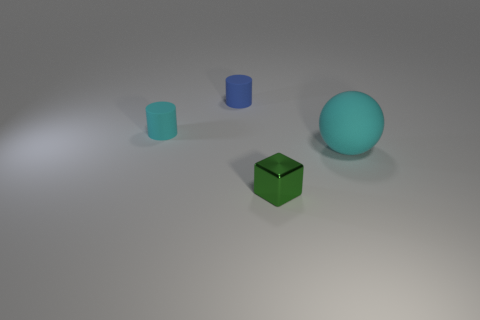Add 2 small green objects. How many objects exist? 6 Subtract all balls. How many objects are left? 3 Add 1 small cyan objects. How many small cyan objects exist? 2 Subtract 0 yellow blocks. How many objects are left? 4 Subtract all tiny brown rubber cylinders. Subtract all tiny cyan cylinders. How many objects are left? 3 Add 1 shiny things. How many shiny things are left? 2 